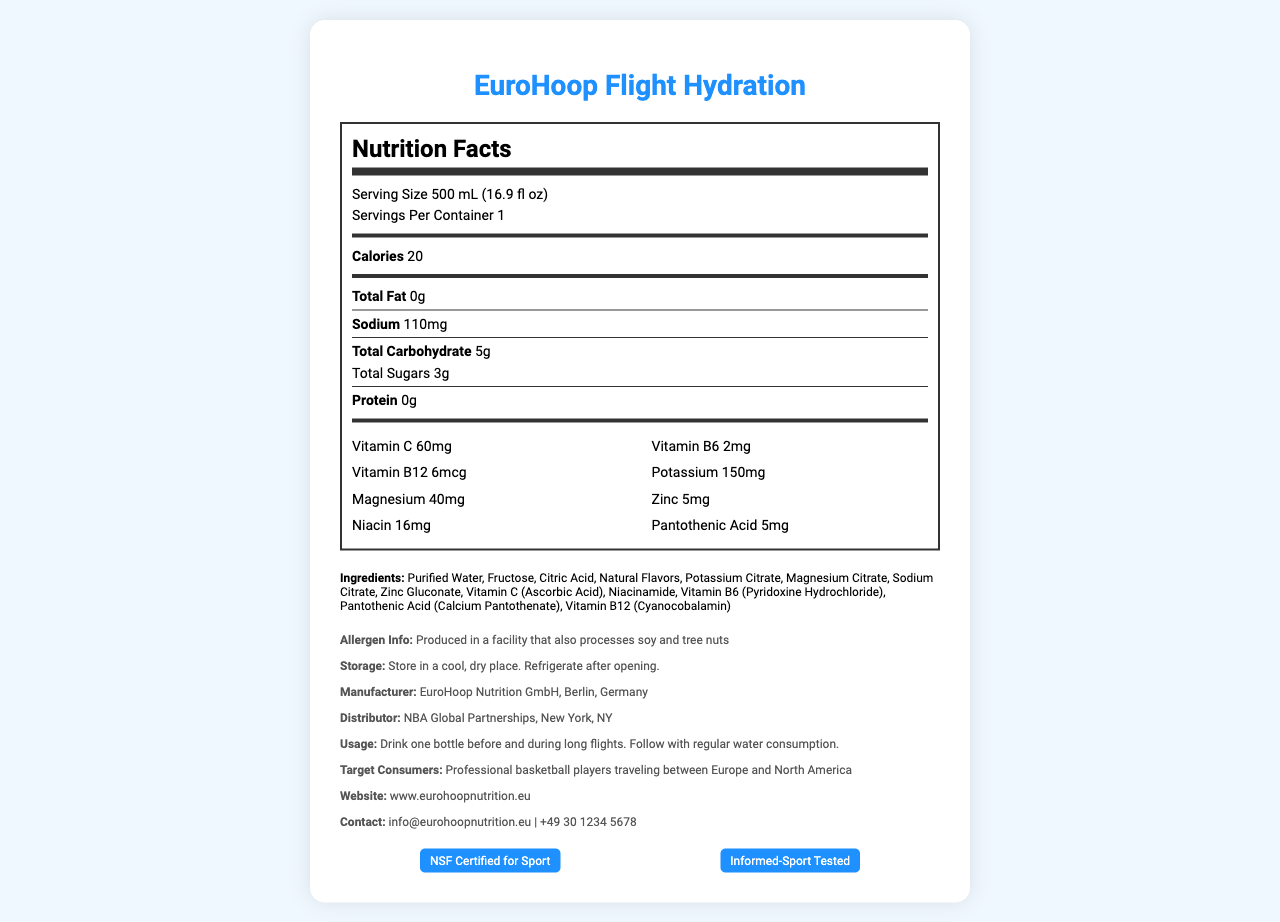what is the serving size? The serving size is listed as "Serving Size 500 mL (16.9 fl oz)" in the nutrition label section.
Answer: 500 mL (16.9 fl oz) how many calories are in one serving? The calories per serving are listed as "Calories 20" in the nutrition label section.
Answer: 20 calories what is the amount of sodium per serving? The amount of sodium per serving is listed as "Sodium 110mg" in the nutrition label section.
Answer: 110mg how much vitamin C does one serving provide? The amount of Vitamin C per serving is listed as "Vitamin C 60mg" in the vitamins section.
Answer: 60mg list the vitamins included in this product. The vitamins included are listed in the vitamins section and are Vitamin C, Vitamin B6, Vitamin B12, Niacin, and Pantothenic Acid.
Answer: Vitamin C, Vitamin B6, Vitamin B12, Niacin, Pantothenic Acid what is the main ingredient of this product? The first ingredient listed is "Purified Water," indicating it is the main ingredient.
Answer: Purified Water which of the following is a correct product claim for EuroHoop Flight Hydration? A. Supports heart health B. Helps with digestion C. Enhances electrolyte balance D. Promotes bone health Enhances electrolyte balance is listed as one of the product claims.
Answer: C what two types of nuts are processed in the facility where this product is made? A. Almonds and peanuts B. Walnuts and cashews C. Soy and tree nuts D. Pistachios and pecans The allergen info states, "Produced in a facility that also processes soy and tree nuts."
Answer: C which vitamins have a milligram (mg) amount listed in the document? A. Vitamin C, Vitamin B6, Vitamin B12 B. Vitamin C, Vitamin B6, Niacin, Pantothenic Acid C. Niacin, Vitamin B12, Pantothenic Acid, Zinc D. Vitamin B6, Vitamin B12, Potassium, Magnesium Vitamins listed with milligram amounts are Vitamin C (60mg), Vitamin B6 (2mg), Niacin (16mg), and Pantothenic Acid (5mg).
Answer: B is this product recommended for short domestic flights? The product claims mention that it supports hydration during long-haul flights, not short domestic flights.
Answer: No describe the main idea of this document. The document contains comprehensive information about EuroHoop Flight Hydration, detailing its nutrition facts, ingredients, manufacturer, usage instructions, product claims, target consumers, and certifications.
Answer: The document presents the Nutrition Facts for EuroHoop Flight Hydration, a vitamin-fortified water designed for international athletes, especially basketball players. It includes serving size, nutritional information, ingredient list, allergen info, storage instructions, manufacturer details, product claims, usage instructions, target consumers, certifications, and contact information. what is the expiry date of this product? The document does not provide any information regarding the expiry date of the product.
Answer: Not enough information 